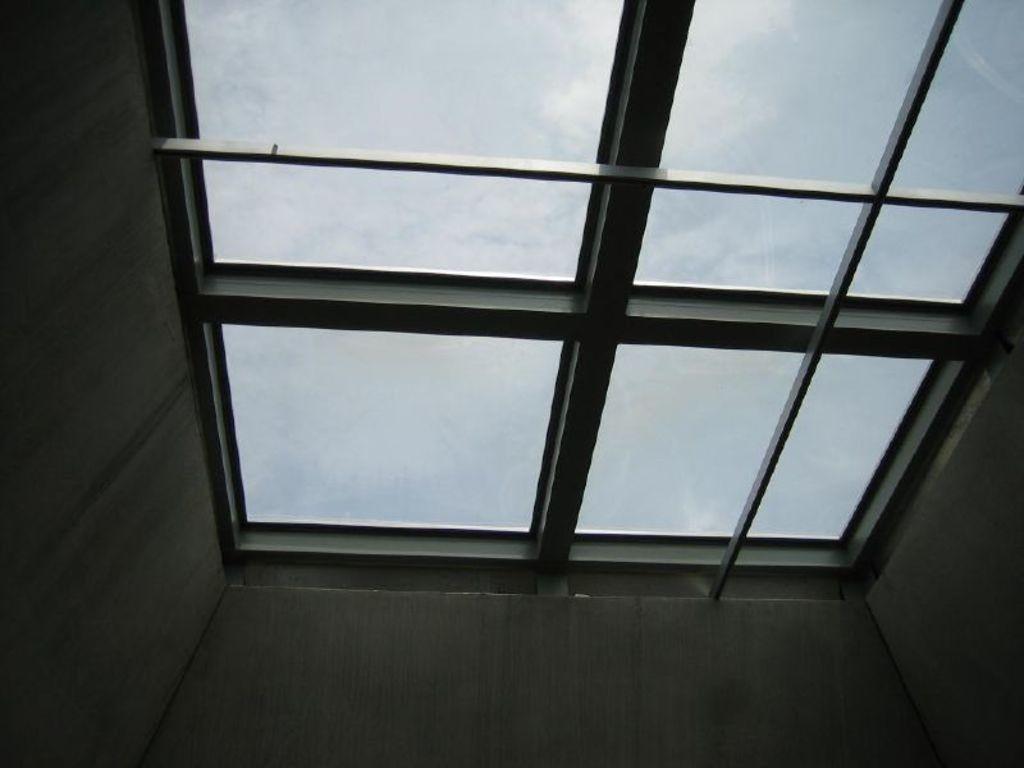Could you give a brief overview of what you see in this image? In this image we can see a window on roof of a building. in the background ,we can see the sky. 